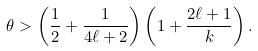<formula> <loc_0><loc_0><loc_500><loc_500>\theta > \left ( \frac { 1 } { 2 } + \frac { 1 } { 4 \ell + 2 } \right ) \left ( 1 + \frac { 2 \ell + 1 } { k } \right ) .</formula> 